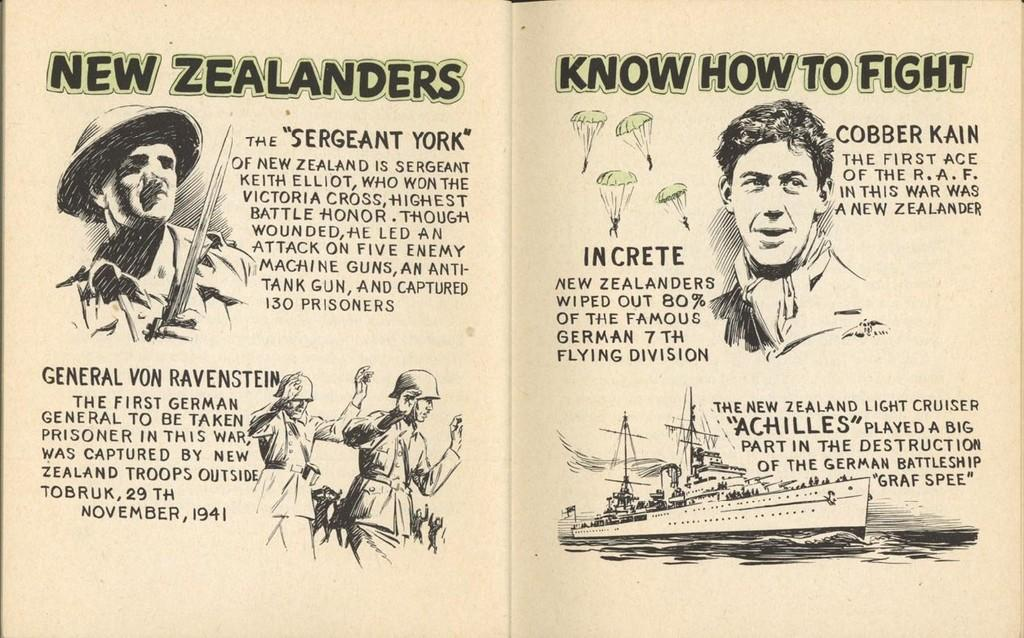What is the main subject of the image? The main subject of the image is a book. What can be found inside the book? There is text in the book. Are there any visual elements in the book? Yes, there are images of a few persons in the book. What type of locket can be seen hanging from the neck of one of the persons in the image? There is no locket visible in the image; it is a picture of a book with text and images of persons. 